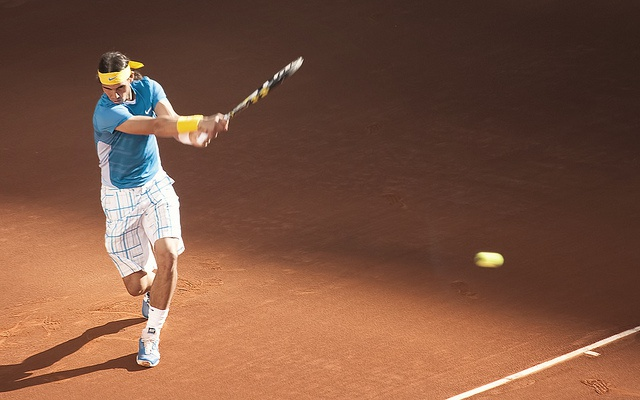Describe the objects in this image and their specific colors. I can see people in black, white, salmon, blue, and teal tones, tennis racket in black, maroon, gray, and ivory tones, and sports ball in black, khaki, lightyellow, and olive tones in this image. 